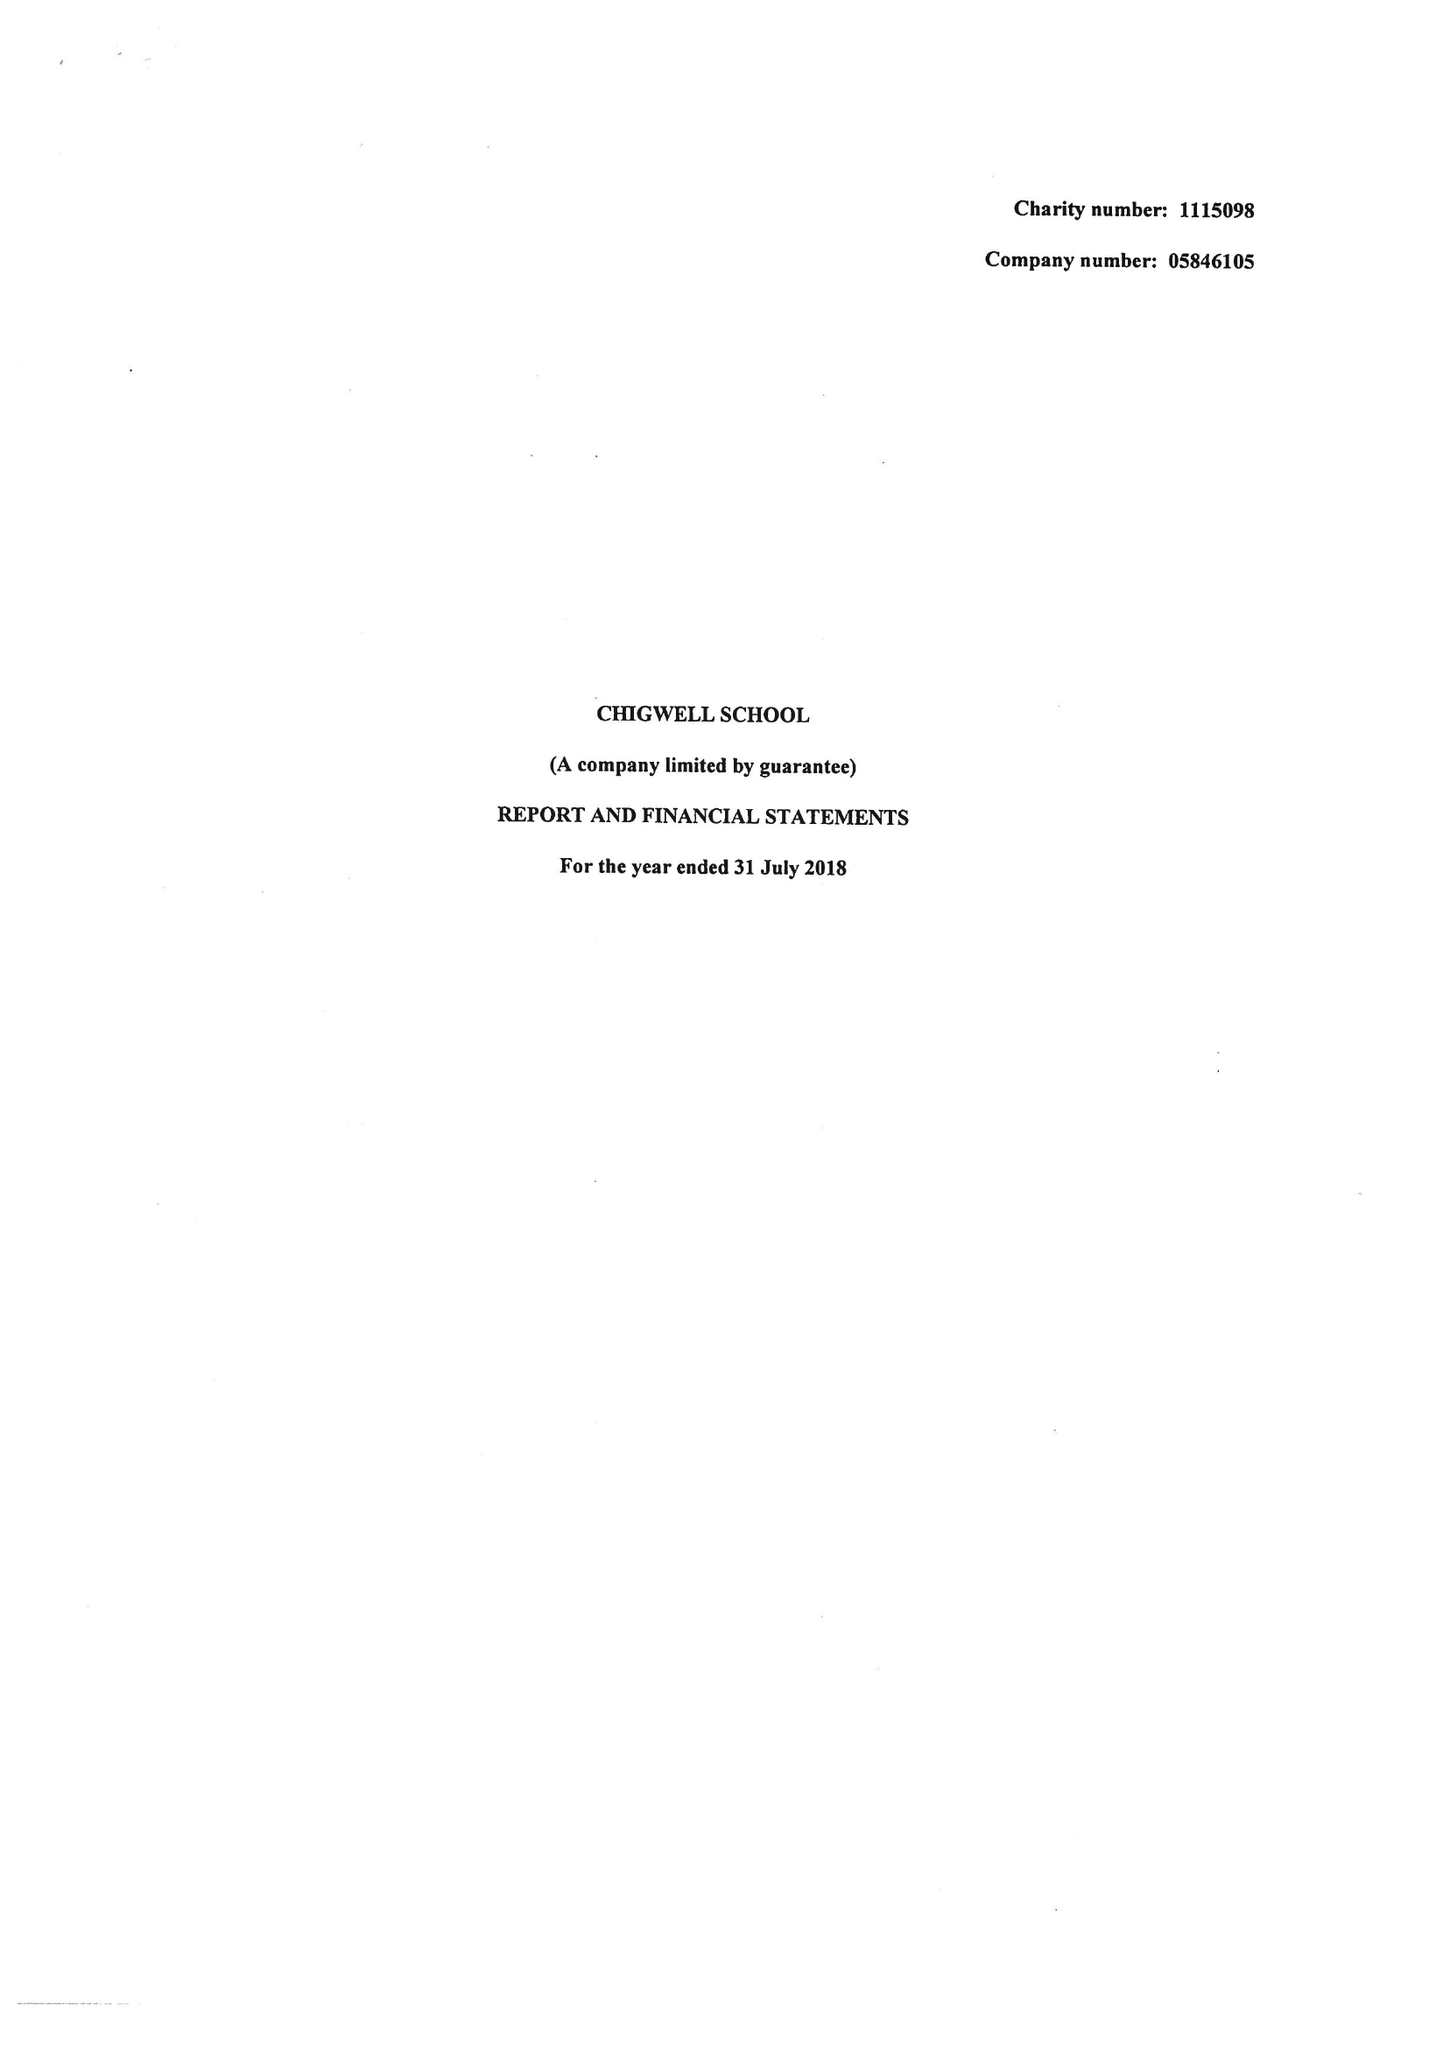What is the value for the income_annually_in_british_pounds?
Answer the question using a single word or phrase. 14032534.00 